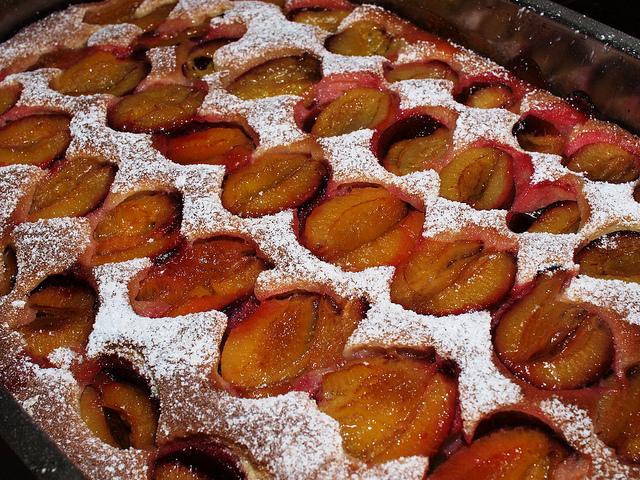What kind of fruit is it?
Give a very brief answer. Peach. Doesn't this dessert look delicious?
Keep it brief. Yes. What is the powdered food?
Keep it brief. Sugar. 